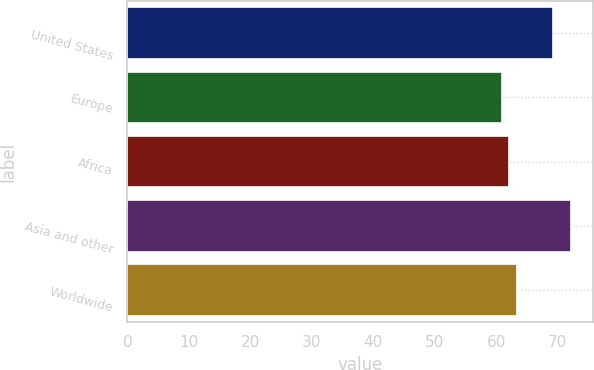Convert chart. <chart><loc_0><loc_0><loc_500><loc_500><bar_chart><fcel>United States<fcel>Europe<fcel>Africa<fcel>Asia and other<fcel>Worldwide<nl><fcel>69.23<fcel>60.99<fcel>62.11<fcel>72.17<fcel>63.44<nl></chart> 